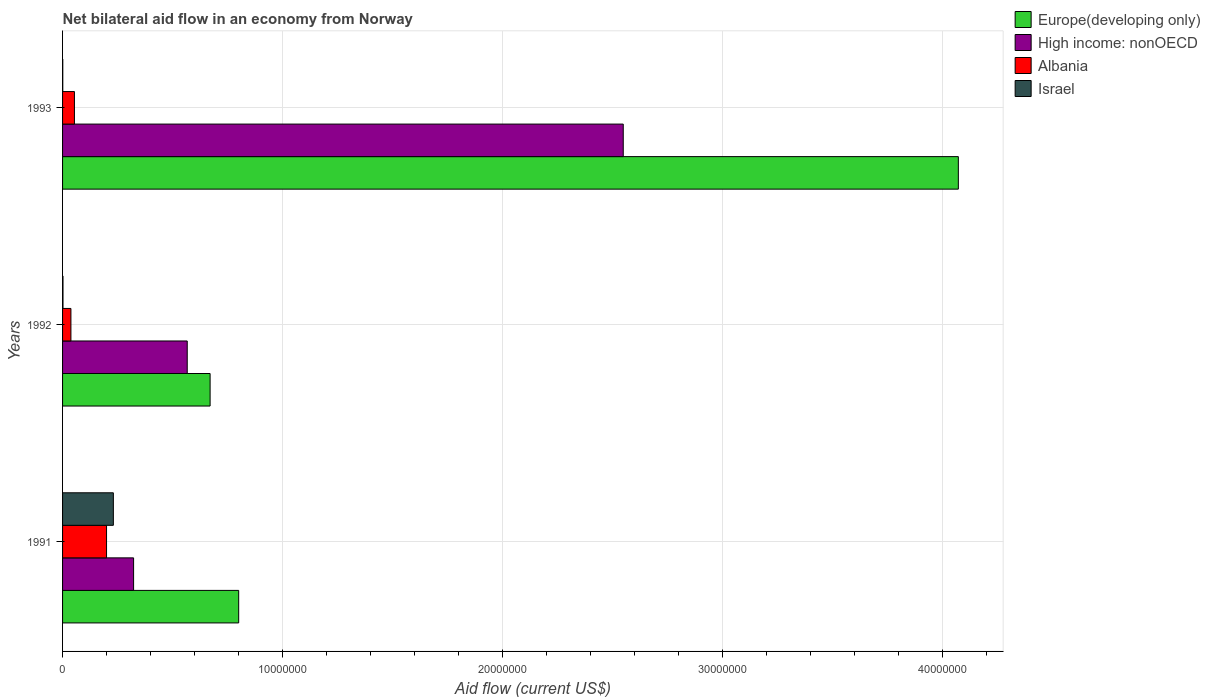How many groups of bars are there?
Provide a short and direct response. 3. Are the number of bars per tick equal to the number of legend labels?
Your answer should be compact. Yes. How many bars are there on the 3rd tick from the bottom?
Keep it short and to the point. 4. What is the label of the 3rd group of bars from the top?
Give a very brief answer. 1991. In how many cases, is the number of bars for a given year not equal to the number of legend labels?
Provide a short and direct response. 0. What is the net bilateral aid flow in Albania in 1992?
Your response must be concise. 3.80e+05. Across all years, what is the maximum net bilateral aid flow in Israel?
Ensure brevity in your answer.  2.31e+06. Across all years, what is the minimum net bilateral aid flow in High income: nonOECD?
Your answer should be compact. 3.23e+06. In which year was the net bilateral aid flow in Israel maximum?
Give a very brief answer. 1991. In which year was the net bilateral aid flow in Israel minimum?
Offer a terse response. 1993. What is the total net bilateral aid flow in High income: nonOECD in the graph?
Your answer should be very brief. 3.44e+07. What is the difference between the net bilateral aid flow in High income: nonOECD in 1991 and that in 1993?
Ensure brevity in your answer.  -2.23e+07. What is the difference between the net bilateral aid flow in Albania in 1993 and the net bilateral aid flow in Europe(developing only) in 1992?
Make the answer very short. -6.17e+06. What is the average net bilateral aid flow in Europe(developing only) per year?
Provide a succinct answer. 1.85e+07. In how many years, is the net bilateral aid flow in High income: nonOECD greater than 24000000 US$?
Keep it short and to the point. 1. What is the ratio of the net bilateral aid flow in Israel in 1991 to that in 1993?
Your answer should be compact. 231. Is the difference between the net bilateral aid flow in Israel in 1991 and 1992 greater than the difference between the net bilateral aid flow in Albania in 1991 and 1992?
Provide a succinct answer. Yes. What is the difference between the highest and the second highest net bilateral aid flow in Albania?
Make the answer very short. 1.46e+06. What is the difference between the highest and the lowest net bilateral aid flow in Israel?
Provide a succinct answer. 2.30e+06. Is it the case that in every year, the sum of the net bilateral aid flow in High income: nonOECD and net bilateral aid flow in Albania is greater than the sum of net bilateral aid flow in Israel and net bilateral aid flow in Europe(developing only)?
Keep it short and to the point. Yes. What does the 3rd bar from the top in 1991 represents?
Provide a succinct answer. High income: nonOECD. What does the 2nd bar from the bottom in 1993 represents?
Your answer should be very brief. High income: nonOECD. Are the values on the major ticks of X-axis written in scientific E-notation?
Offer a very short reply. No. Does the graph contain grids?
Your answer should be compact. Yes. How many legend labels are there?
Your answer should be compact. 4. How are the legend labels stacked?
Offer a terse response. Vertical. What is the title of the graph?
Ensure brevity in your answer.  Net bilateral aid flow in an economy from Norway. What is the label or title of the X-axis?
Your answer should be compact. Aid flow (current US$). What is the Aid flow (current US$) of Europe(developing only) in 1991?
Ensure brevity in your answer.  8.01e+06. What is the Aid flow (current US$) in High income: nonOECD in 1991?
Make the answer very short. 3.23e+06. What is the Aid flow (current US$) in Albania in 1991?
Ensure brevity in your answer.  2.00e+06. What is the Aid flow (current US$) in Israel in 1991?
Give a very brief answer. 2.31e+06. What is the Aid flow (current US$) of Europe(developing only) in 1992?
Make the answer very short. 6.71e+06. What is the Aid flow (current US$) in High income: nonOECD in 1992?
Ensure brevity in your answer.  5.67e+06. What is the Aid flow (current US$) in Europe(developing only) in 1993?
Provide a succinct answer. 4.07e+07. What is the Aid flow (current US$) in High income: nonOECD in 1993?
Your response must be concise. 2.55e+07. What is the Aid flow (current US$) of Albania in 1993?
Keep it short and to the point. 5.40e+05. What is the Aid flow (current US$) of Israel in 1993?
Keep it short and to the point. 10000. Across all years, what is the maximum Aid flow (current US$) in Europe(developing only)?
Ensure brevity in your answer.  4.07e+07. Across all years, what is the maximum Aid flow (current US$) of High income: nonOECD?
Ensure brevity in your answer.  2.55e+07. Across all years, what is the maximum Aid flow (current US$) of Albania?
Offer a terse response. 2.00e+06. Across all years, what is the maximum Aid flow (current US$) in Israel?
Offer a very short reply. 2.31e+06. Across all years, what is the minimum Aid flow (current US$) of Europe(developing only)?
Your answer should be very brief. 6.71e+06. Across all years, what is the minimum Aid flow (current US$) in High income: nonOECD?
Ensure brevity in your answer.  3.23e+06. Across all years, what is the minimum Aid flow (current US$) of Albania?
Your answer should be very brief. 3.80e+05. What is the total Aid flow (current US$) of Europe(developing only) in the graph?
Keep it short and to the point. 5.55e+07. What is the total Aid flow (current US$) in High income: nonOECD in the graph?
Your response must be concise. 3.44e+07. What is the total Aid flow (current US$) of Albania in the graph?
Give a very brief answer. 2.92e+06. What is the total Aid flow (current US$) in Israel in the graph?
Provide a succinct answer. 2.34e+06. What is the difference between the Aid flow (current US$) in Europe(developing only) in 1991 and that in 1992?
Make the answer very short. 1.30e+06. What is the difference between the Aid flow (current US$) of High income: nonOECD in 1991 and that in 1992?
Keep it short and to the point. -2.44e+06. What is the difference between the Aid flow (current US$) of Albania in 1991 and that in 1992?
Give a very brief answer. 1.62e+06. What is the difference between the Aid flow (current US$) in Israel in 1991 and that in 1992?
Provide a succinct answer. 2.29e+06. What is the difference between the Aid flow (current US$) in Europe(developing only) in 1991 and that in 1993?
Ensure brevity in your answer.  -3.27e+07. What is the difference between the Aid flow (current US$) in High income: nonOECD in 1991 and that in 1993?
Provide a short and direct response. -2.23e+07. What is the difference between the Aid flow (current US$) of Albania in 1991 and that in 1993?
Provide a succinct answer. 1.46e+06. What is the difference between the Aid flow (current US$) in Israel in 1991 and that in 1993?
Your response must be concise. 2.30e+06. What is the difference between the Aid flow (current US$) of Europe(developing only) in 1992 and that in 1993?
Ensure brevity in your answer.  -3.40e+07. What is the difference between the Aid flow (current US$) of High income: nonOECD in 1992 and that in 1993?
Give a very brief answer. -1.98e+07. What is the difference between the Aid flow (current US$) of Europe(developing only) in 1991 and the Aid flow (current US$) of High income: nonOECD in 1992?
Provide a succinct answer. 2.34e+06. What is the difference between the Aid flow (current US$) of Europe(developing only) in 1991 and the Aid flow (current US$) of Albania in 1992?
Keep it short and to the point. 7.63e+06. What is the difference between the Aid flow (current US$) of Europe(developing only) in 1991 and the Aid flow (current US$) of Israel in 1992?
Provide a short and direct response. 7.99e+06. What is the difference between the Aid flow (current US$) of High income: nonOECD in 1991 and the Aid flow (current US$) of Albania in 1992?
Make the answer very short. 2.85e+06. What is the difference between the Aid flow (current US$) in High income: nonOECD in 1991 and the Aid flow (current US$) in Israel in 1992?
Your answer should be very brief. 3.21e+06. What is the difference between the Aid flow (current US$) of Albania in 1991 and the Aid flow (current US$) of Israel in 1992?
Ensure brevity in your answer.  1.98e+06. What is the difference between the Aid flow (current US$) in Europe(developing only) in 1991 and the Aid flow (current US$) in High income: nonOECD in 1993?
Provide a short and direct response. -1.75e+07. What is the difference between the Aid flow (current US$) of Europe(developing only) in 1991 and the Aid flow (current US$) of Albania in 1993?
Offer a terse response. 7.47e+06. What is the difference between the Aid flow (current US$) in High income: nonOECD in 1991 and the Aid flow (current US$) in Albania in 1993?
Provide a succinct answer. 2.69e+06. What is the difference between the Aid flow (current US$) of High income: nonOECD in 1991 and the Aid flow (current US$) of Israel in 1993?
Your answer should be very brief. 3.22e+06. What is the difference between the Aid flow (current US$) of Albania in 1991 and the Aid flow (current US$) of Israel in 1993?
Make the answer very short. 1.99e+06. What is the difference between the Aid flow (current US$) of Europe(developing only) in 1992 and the Aid flow (current US$) of High income: nonOECD in 1993?
Provide a succinct answer. -1.88e+07. What is the difference between the Aid flow (current US$) of Europe(developing only) in 1992 and the Aid flow (current US$) of Albania in 1993?
Provide a short and direct response. 6.17e+06. What is the difference between the Aid flow (current US$) in Europe(developing only) in 1992 and the Aid flow (current US$) in Israel in 1993?
Offer a very short reply. 6.70e+06. What is the difference between the Aid flow (current US$) of High income: nonOECD in 1992 and the Aid flow (current US$) of Albania in 1993?
Provide a short and direct response. 5.13e+06. What is the difference between the Aid flow (current US$) in High income: nonOECD in 1992 and the Aid flow (current US$) in Israel in 1993?
Give a very brief answer. 5.66e+06. What is the difference between the Aid flow (current US$) in Albania in 1992 and the Aid flow (current US$) in Israel in 1993?
Your response must be concise. 3.70e+05. What is the average Aid flow (current US$) in Europe(developing only) per year?
Keep it short and to the point. 1.85e+07. What is the average Aid flow (current US$) in High income: nonOECD per year?
Offer a very short reply. 1.15e+07. What is the average Aid flow (current US$) in Albania per year?
Offer a very short reply. 9.73e+05. What is the average Aid flow (current US$) of Israel per year?
Offer a very short reply. 7.80e+05. In the year 1991, what is the difference between the Aid flow (current US$) of Europe(developing only) and Aid flow (current US$) of High income: nonOECD?
Keep it short and to the point. 4.78e+06. In the year 1991, what is the difference between the Aid flow (current US$) in Europe(developing only) and Aid flow (current US$) in Albania?
Provide a short and direct response. 6.01e+06. In the year 1991, what is the difference between the Aid flow (current US$) in Europe(developing only) and Aid flow (current US$) in Israel?
Offer a very short reply. 5.70e+06. In the year 1991, what is the difference between the Aid flow (current US$) of High income: nonOECD and Aid flow (current US$) of Albania?
Offer a terse response. 1.23e+06. In the year 1991, what is the difference between the Aid flow (current US$) of High income: nonOECD and Aid flow (current US$) of Israel?
Offer a very short reply. 9.20e+05. In the year 1991, what is the difference between the Aid flow (current US$) in Albania and Aid flow (current US$) in Israel?
Keep it short and to the point. -3.10e+05. In the year 1992, what is the difference between the Aid flow (current US$) of Europe(developing only) and Aid flow (current US$) of High income: nonOECD?
Keep it short and to the point. 1.04e+06. In the year 1992, what is the difference between the Aid flow (current US$) in Europe(developing only) and Aid flow (current US$) in Albania?
Provide a succinct answer. 6.33e+06. In the year 1992, what is the difference between the Aid flow (current US$) in Europe(developing only) and Aid flow (current US$) in Israel?
Make the answer very short. 6.69e+06. In the year 1992, what is the difference between the Aid flow (current US$) of High income: nonOECD and Aid flow (current US$) of Albania?
Provide a succinct answer. 5.29e+06. In the year 1992, what is the difference between the Aid flow (current US$) of High income: nonOECD and Aid flow (current US$) of Israel?
Your answer should be very brief. 5.65e+06. In the year 1992, what is the difference between the Aid flow (current US$) in Albania and Aid flow (current US$) in Israel?
Your response must be concise. 3.60e+05. In the year 1993, what is the difference between the Aid flow (current US$) of Europe(developing only) and Aid flow (current US$) of High income: nonOECD?
Give a very brief answer. 1.52e+07. In the year 1993, what is the difference between the Aid flow (current US$) in Europe(developing only) and Aid flow (current US$) in Albania?
Your answer should be compact. 4.02e+07. In the year 1993, what is the difference between the Aid flow (current US$) of Europe(developing only) and Aid flow (current US$) of Israel?
Provide a succinct answer. 4.07e+07. In the year 1993, what is the difference between the Aid flow (current US$) of High income: nonOECD and Aid flow (current US$) of Albania?
Provide a short and direct response. 2.50e+07. In the year 1993, what is the difference between the Aid flow (current US$) in High income: nonOECD and Aid flow (current US$) in Israel?
Ensure brevity in your answer.  2.55e+07. In the year 1993, what is the difference between the Aid flow (current US$) in Albania and Aid flow (current US$) in Israel?
Provide a short and direct response. 5.30e+05. What is the ratio of the Aid flow (current US$) of Europe(developing only) in 1991 to that in 1992?
Make the answer very short. 1.19. What is the ratio of the Aid flow (current US$) of High income: nonOECD in 1991 to that in 1992?
Your answer should be very brief. 0.57. What is the ratio of the Aid flow (current US$) in Albania in 1991 to that in 1992?
Offer a very short reply. 5.26. What is the ratio of the Aid flow (current US$) of Israel in 1991 to that in 1992?
Keep it short and to the point. 115.5. What is the ratio of the Aid flow (current US$) of Europe(developing only) in 1991 to that in 1993?
Make the answer very short. 0.2. What is the ratio of the Aid flow (current US$) of High income: nonOECD in 1991 to that in 1993?
Your answer should be compact. 0.13. What is the ratio of the Aid flow (current US$) in Albania in 1991 to that in 1993?
Ensure brevity in your answer.  3.7. What is the ratio of the Aid flow (current US$) in Israel in 1991 to that in 1993?
Your answer should be very brief. 231. What is the ratio of the Aid flow (current US$) in Europe(developing only) in 1992 to that in 1993?
Your response must be concise. 0.16. What is the ratio of the Aid flow (current US$) in High income: nonOECD in 1992 to that in 1993?
Your answer should be very brief. 0.22. What is the ratio of the Aid flow (current US$) in Albania in 1992 to that in 1993?
Give a very brief answer. 0.7. What is the ratio of the Aid flow (current US$) of Israel in 1992 to that in 1993?
Your response must be concise. 2. What is the difference between the highest and the second highest Aid flow (current US$) of Europe(developing only)?
Your answer should be compact. 3.27e+07. What is the difference between the highest and the second highest Aid flow (current US$) in High income: nonOECD?
Make the answer very short. 1.98e+07. What is the difference between the highest and the second highest Aid flow (current US$) of Albania?
Make the answer very short. 1.46e+06. What is the difference between the highest and the second highest Aid flow (current US$) of Israel?
Your answer should be very brief. 2.29e+06. What is the difference between the highest and the lowest Aid flow (current US$) of Europe(developing only)?
Provide a short and direct response. 3.40e+07. What is the difference between the highest and the lowest Aid flow (current US$) of High income: nonOECD?
Offer a very short reply. 2.23e+07. What is the difference between the highest and the lowest Aid flow (current US$) of Albania?
Give a very brief answer. 1.62e+06. What is the difference between the highest and the lowest Aid flow (current US$) in Israel?
Ensure brevity in your answer.  2.30e+06. 